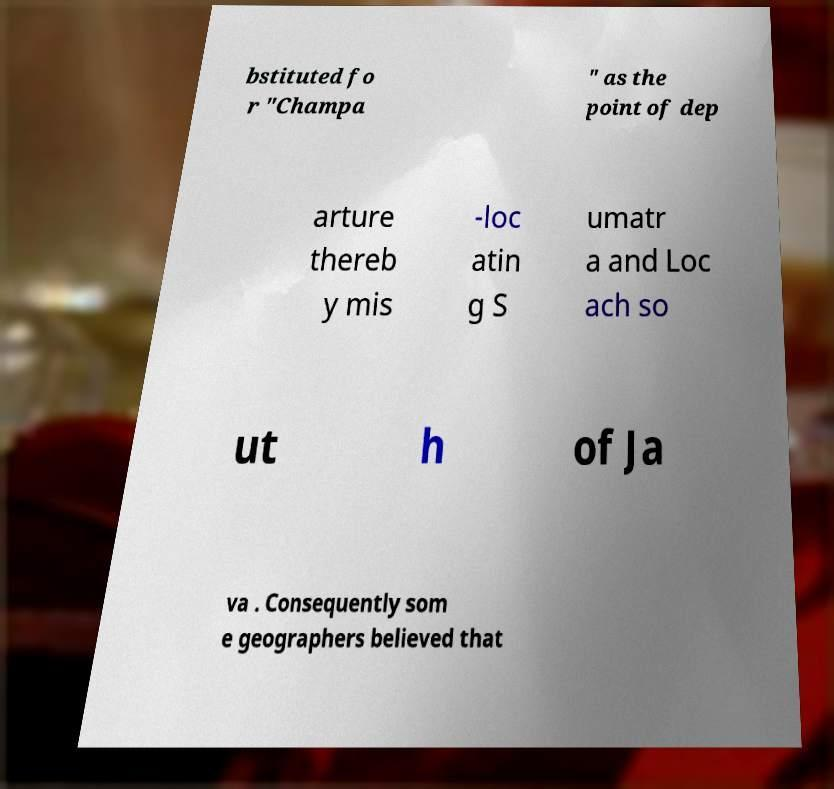I need the written content from this picture converted into text. Can you do that? bstituted fo r "Champa " as the point of dep arture thereb y mis -loc atin g S umatr a and Loc ach so ut h of Ja va . Consequently som e geographers believed that 